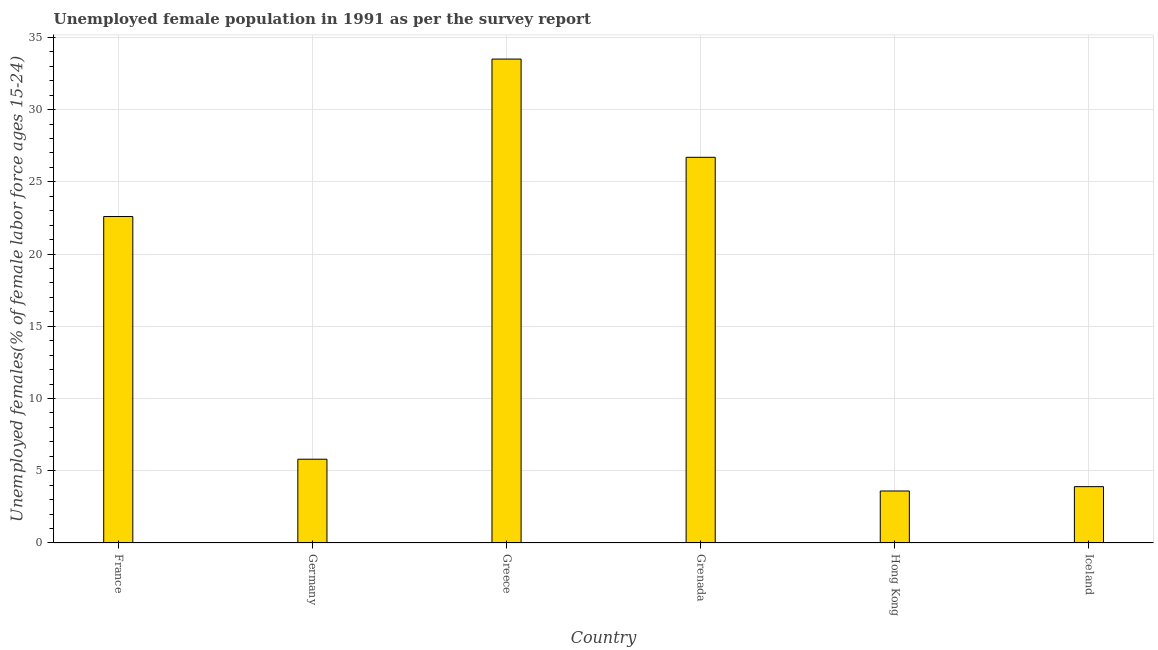Does the graph contain grids?
Keep it short and to the point. Yes. What is the title of the graph?
Ensure brevity in your answer.  Unemployed female population in 1991 as per the survey report. What is the label or title of the Y-axis?
Offer a terse response. Unemployed females(% of female labor force ages 15-24). What is the unemployed female youth in Germany?
Make the answer very short. 5.8. Across all countries, what is the maximum unemployed female youth?
Make the answer very short. 33.5. Across all countries, what is the minimum unemployed female youth?
Give a very brief answer. 3.6. In which country was the unemployed female youth maximum?
Your response must be concise. Greece. In which country was the unemployed female youth minimum?
Offer a terse response. Hong Kong. What is the sum of the unemployed female youth?
Your answer should be very brief. 96.1. What is the average unemployed female youth per country?
Provide a succinct answer. 16.02. What is the median unemployed female youth?
Keep it short and to the point. 14.2. What is the ratio of the unemployed female youth in Greece to that in Hong Kong?
Provide a short and direct response. 9.31. Is the unemployed female youth in Germany less than that in Greece?
Keep it short and to the point. Yes. What is the difference between the highest and the second highest unemployed female youth?
Provide a short and direct response. 6.8. Is the sum of the unemployed female youth in France and Hong Kong greater than the maximum unemployed female youth across all countries?
Keep it short and to the point. No. What is the difference between the highest and the lowest unemployed female youth?
Ensure brevity in your answer.  29.9. In how many countries, is the unemployed female youth greater than the average unemployed female youth taken over all countries?
Provide a short and direct response. 3. How many bars are there?
Keep it short and to the point. 6. Are all the bars in the graph horizontal?
Your answer should be very brief. No. How many countries are there in the graph?
Make the answer very short. 6. What is the Unemployed females(% of female labor force ages 15-24) of France?
Provide a short and direct response. 22.6. What is the Unemployed females(% of female labor force ages 15-24) of Germany?
Your response must be concise. 5.8. What is the Unemployed females(% of female labor force ages 15-24) in Greece?
Keep it short and to the point. 33.5. What is the Unemployed females(% of female labor force ages 15-24) of Grenada?
Make the answer very short. 26.7. What is the Unemployed females(% of female labor force ages 15-24) in Hong Kong?
Offer a terse response. 3.6. What is the Unemployed females(% of female labor force ages 15-24) of Iceland?
Your answer should be compact. 3.9. What is the difference between the Unemployed females(% of female labor force ages 15-24) in France and Germany?
Give a very brief answer. 16.8. What is the difference between the Unemployed females(% of female labor force ages 15-24) in France and Greece?
Your response must be concise. -10.9. What is the difference between the Unemployed females(% of female labor force ages 15-24) in France and Iceland?
Your answer should be very brief. 18.7. What is the difference between the Unemployed females(% of female labor force ages 15-24) in Germany and Greece?
Your response must be concise. -27.7. What is the difference between the Unemployed females(% of female labor force ages 15-24) in Germany and Grenada?
Provide a succinct answer. -20.9. What is the difference between the Unemployed females(% of female labor force ages 15-24) in Greece and Grenada?
Your answer should be compact. 6.8. What is the difference between the Unemployed females(% of female labor force ages 15-24) in Greece and Hong Kong?
Your answer should be very brief. 29.9. What is the difference between the Unemployed females(% of female labor force ages 15-24) in Greece and Iceland?
Provide a succinct answer. 29.6. What is the difference between the Unemployed females(% of female labor force ages 15-24) in Grenada and Hong Kong?
Provide a short and direct response. 23.1. What is the difference between the Unemployed females(% of female labor force ages 15-24) in Grenada and Iceland?
Provide a short and direct response. 22.8. What is the difference between the Unemployed females(% of female labor force ages 15-24) in Hong Kong and Iceland?
Make the answer very short. -0.3. What is the ratio of the Unemployed females(% of female labor force ages 15-24) in France to that in Germany?
Make the answer very short. 3.9. What is the ratio of the Unemployed females(% of female labor force ages 15-24) in France to that in Greece?
Give a very brief answer. 0.68. What is the ratio of the Unemployed females(% of female labor force ages 15-24) in France to that in Grenada?
Your answer should be compact. 0.85. What is the ratio of the Unemployed females(% of female labor force ages 15-24) in France to that in Hong Kong?
Give a very brief answer. 6.28. What is the ratio of the Unemployed females(% of female labor force ages 15-24) in France to that in Iceland?
Provide a succinct answer. 5.79. What is the ratio of the Unemployed females(% of female labor force ages 15-24) in Germany to that in Greece?
Offer a terse response. 0.17. What is the ratio of the Unemployed females(% of female labor force ages 15-24) in Germany to that in Grenada?
Keep it short and to the point. 0.22. What is the ratio of the Unemployed females(% of female labor force ages 15-24) in Germany to that in Hong Kong?
Offer a terse response. 1.61. What is the ratio of the Unemployed females(% of female labor force ages 15-24) in Germany to that in Iceland?
Make the answer very short. 1.49. What is the ratio of the Unemployed females(% of female labor force ages 15-24) in Greece to that in Grenada?
Keep it short and to the point. 1.25. What is the ratio of the Unemployed females(% of female labor force ages 15-24) in Greece to that in Hong Kong?
Offer a terse response. 9.31. What is the ratio of the Unemployed females(% of female labor force ages 15-24) in Greece to that in Iceland?
Ensure brevity in your answer.  8.59. What is the ratio of the Unemployed females(% of female labor force ages 15-24) in Grenada to that in Hong Kong?
Your answer should be compact. 7.42. What is the ratio of the Unemployed females(% of female labor force ages 15-24) in Grenada to that in Iceland?
Your answer should be very brief. 6.85. What is the ratio of the Unemployed females(% of female labor force ages 15-24) in Hong Kong to that in Iceland?
Make the answer very short. 0.92. 